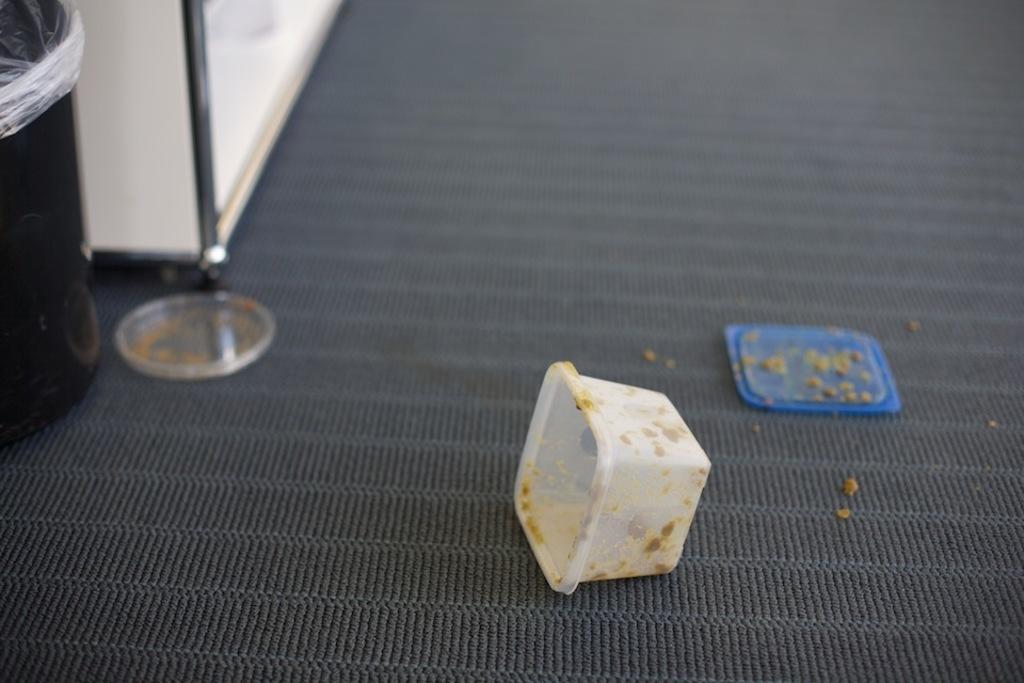Describe this image in one or two sentences. In this picture we can see a dustbin, box, lids and an object on the surface. 